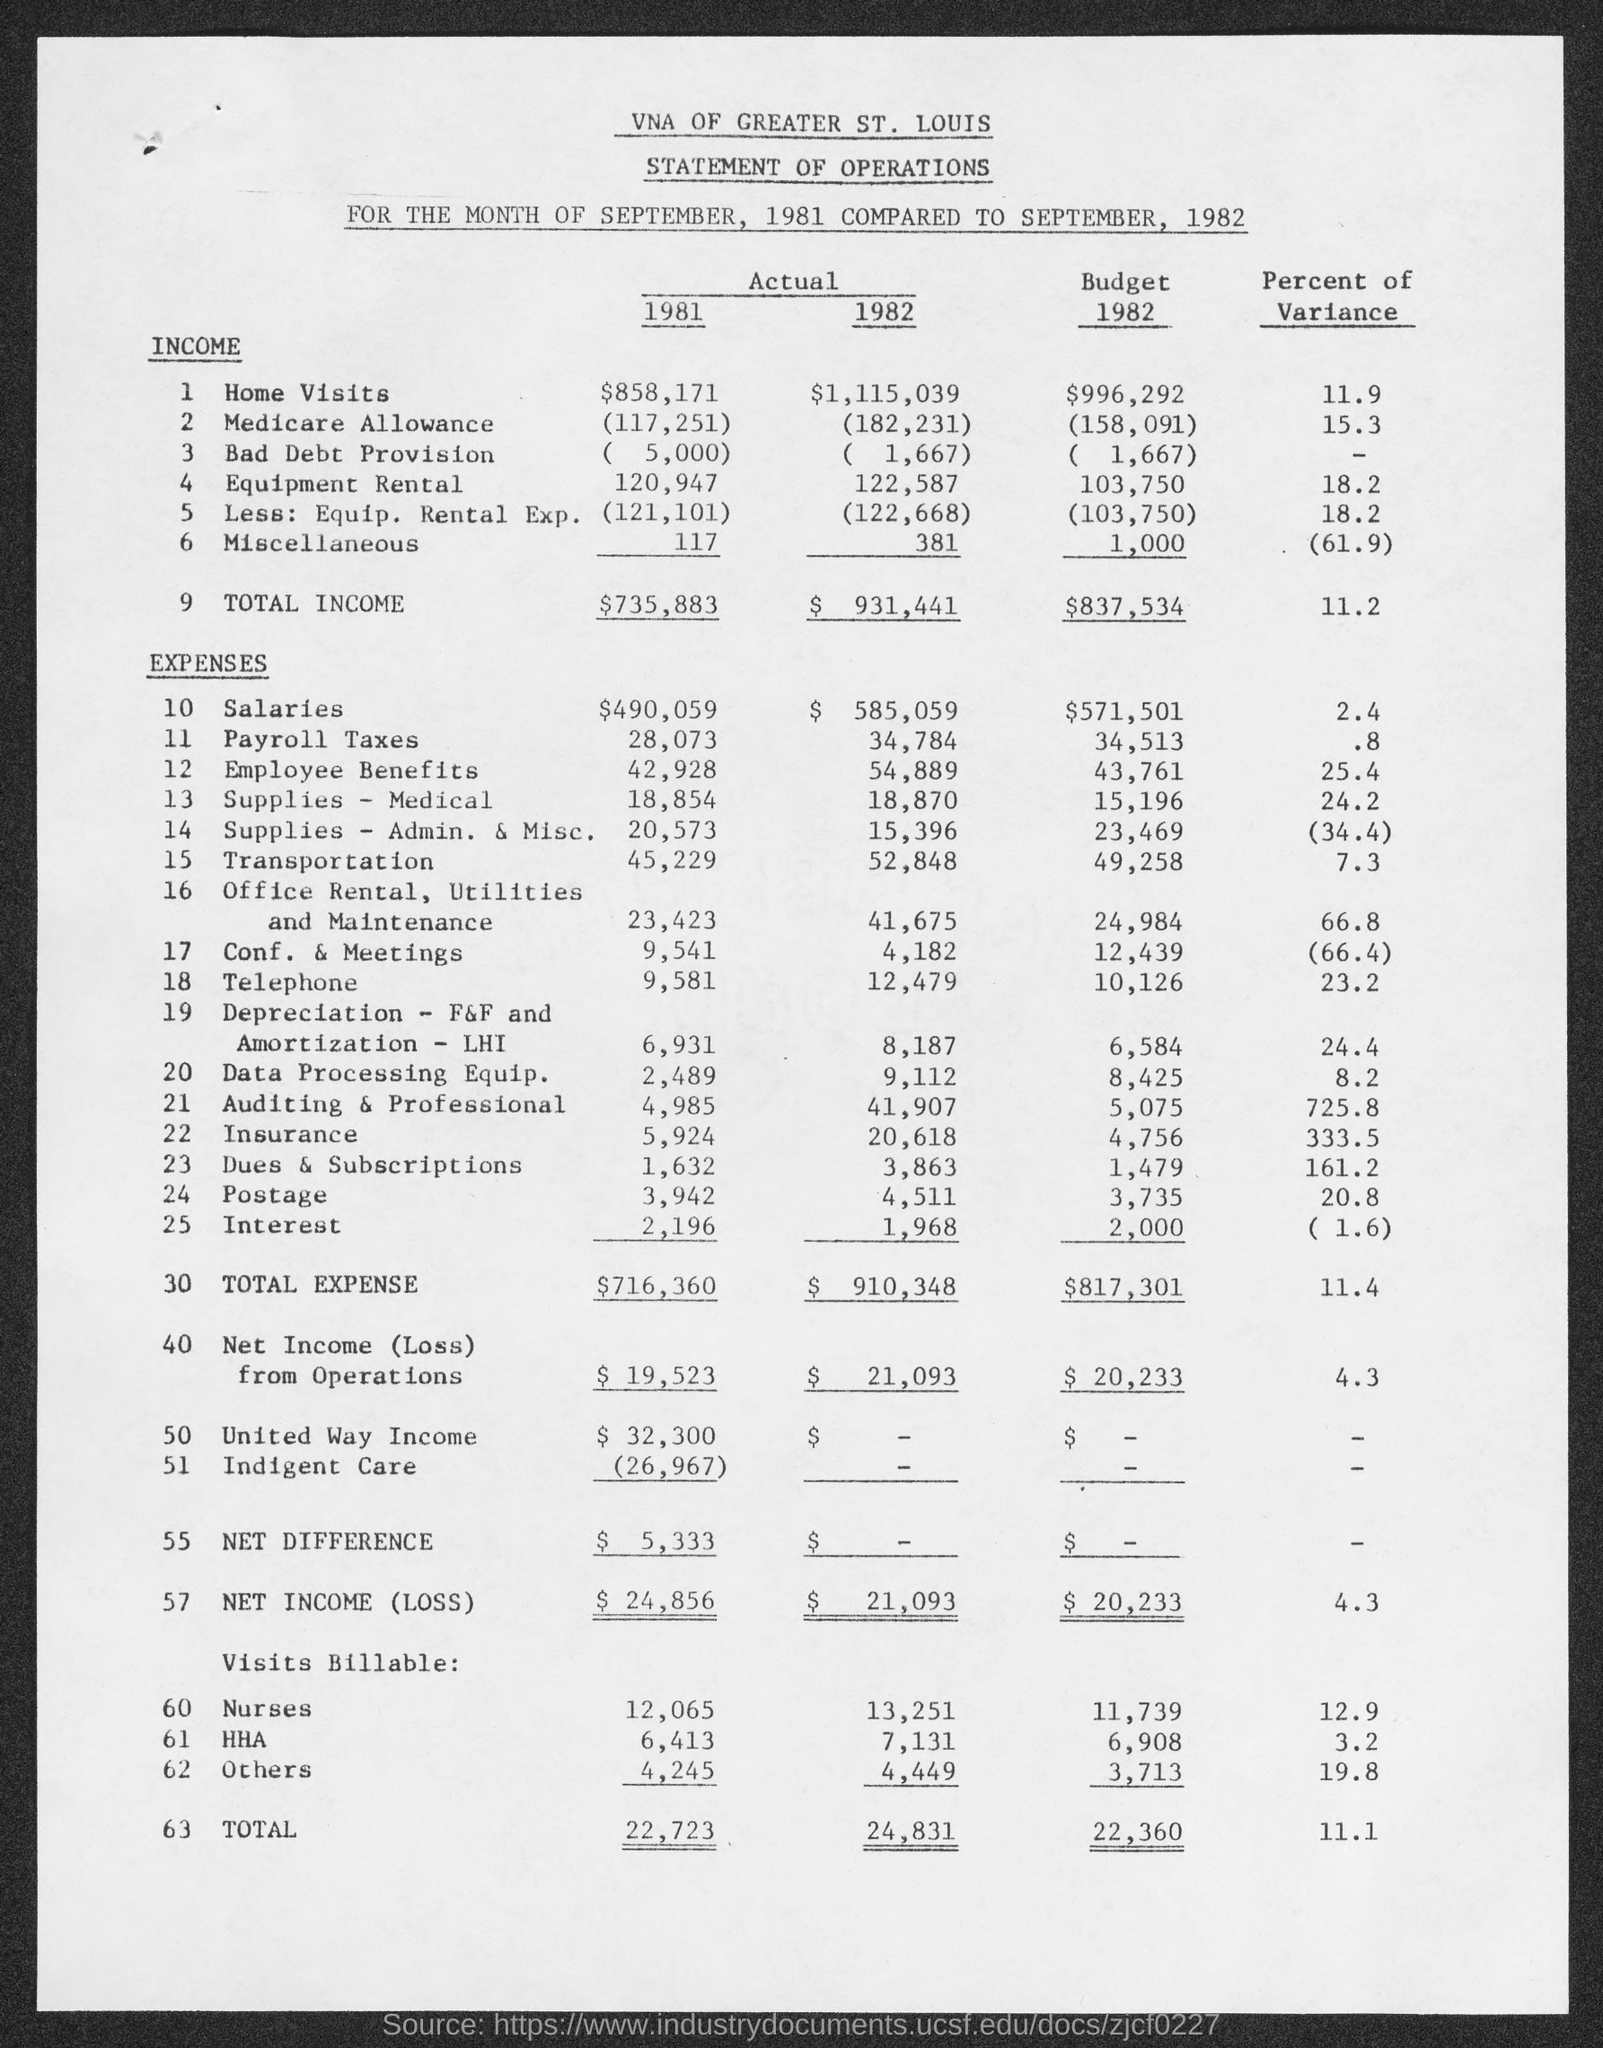Outline some significant characteristics in this image. The actual income for home visits in 1981 was $858,171. The actual income for bad debt provision for 1981 is 5,000. The actual income for equipment rental in 1981 was $120,947. The actual income for Miscellaneous for 1981 is 117. The actual income for bad debt provision for the year 1982 was 1,667. 